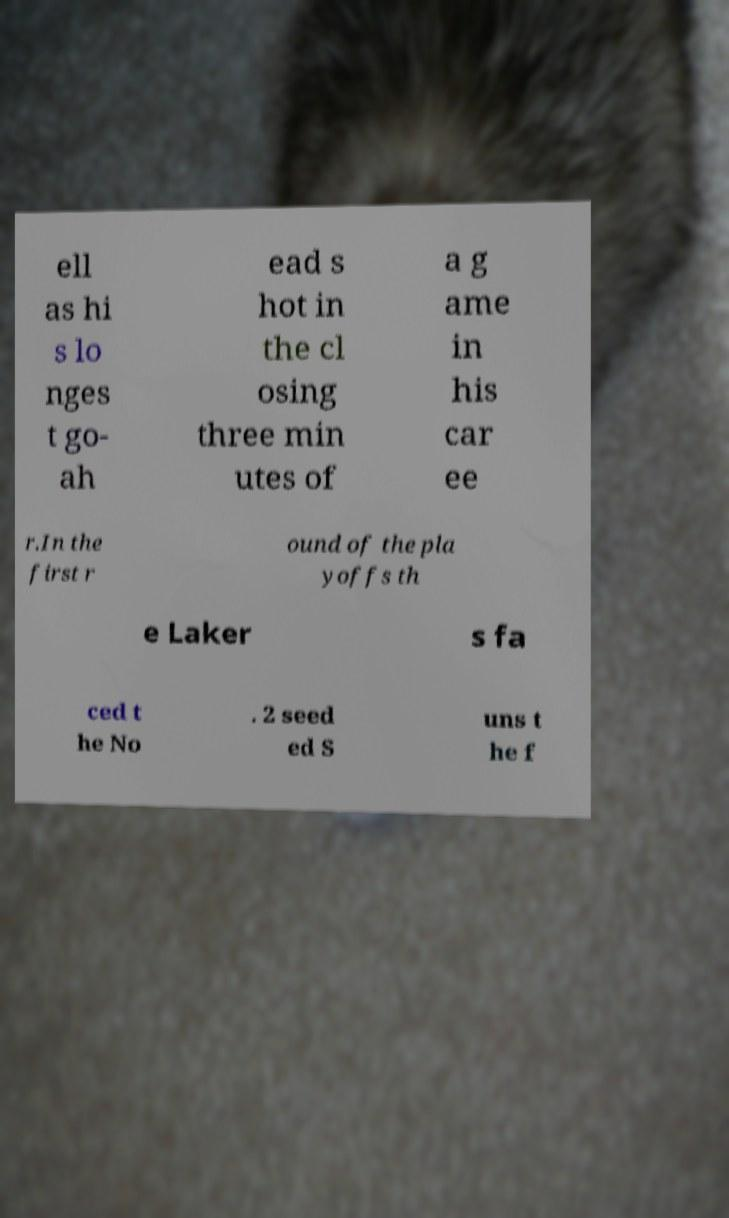I need the written content from this picture converted into text. Can you do that? ell as hi s lo nges t go- ah ead s hot in the cl osing three min utes of a g ame in his car ee r.In the first r ound of the pla yoffs th e Laker s fa ced t he No . 2 seed ed S uns t he f 